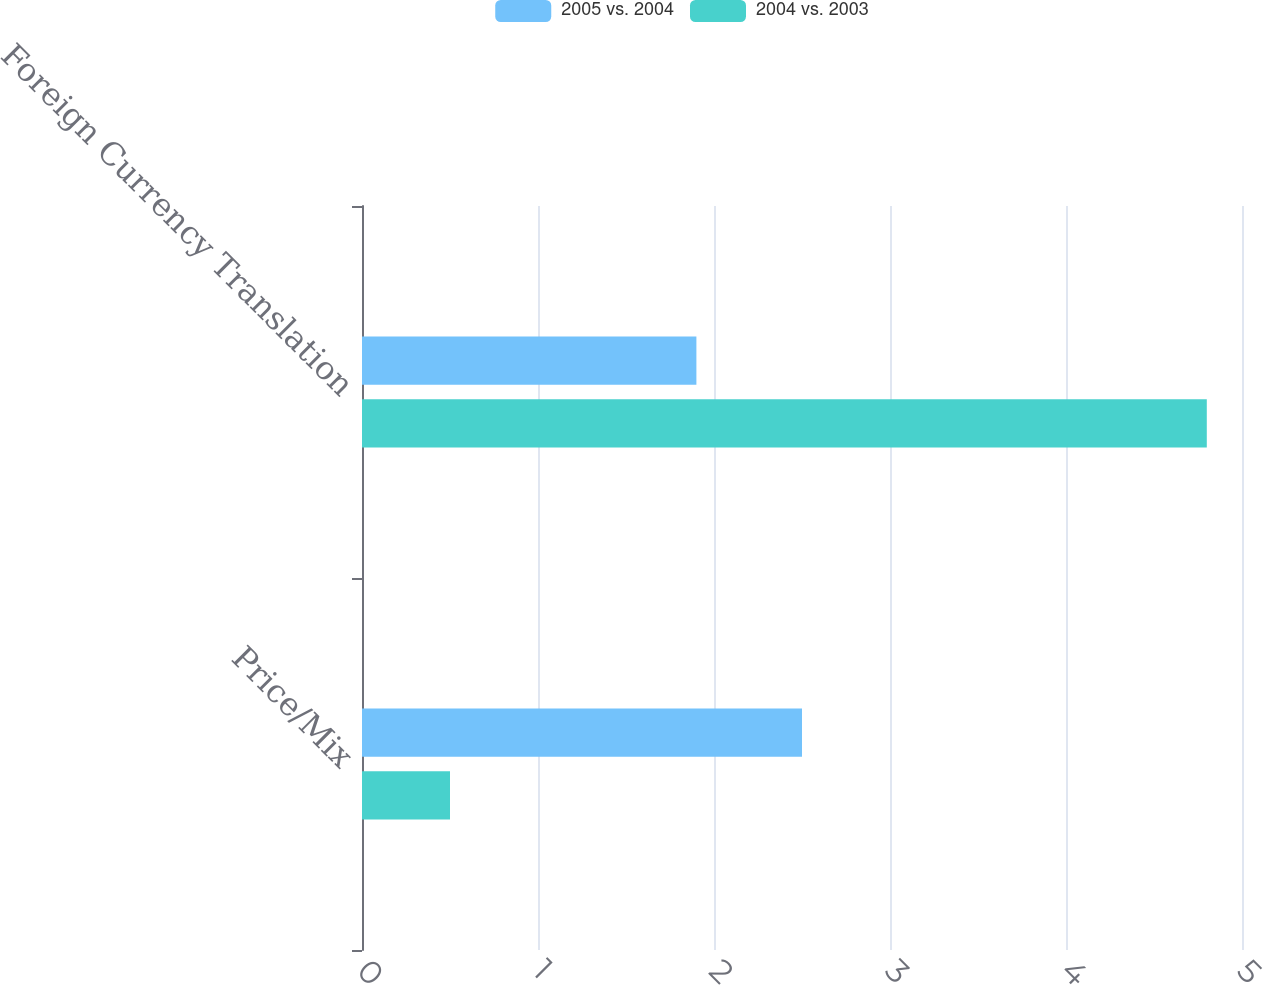Convert chart. <chart><loc_0><loc_0><loc_500><loc_500><stacked_bar_chart><ecel><fcel>Price/Mix<fcel>Foreign Currency Translation<nl><fcel>2005 vs. 2004<fcel>2.5<fcel>1.9<nl><fcel>2004 vs. 2003<fcel>0.5<fcel>4.8<nl></chart> 